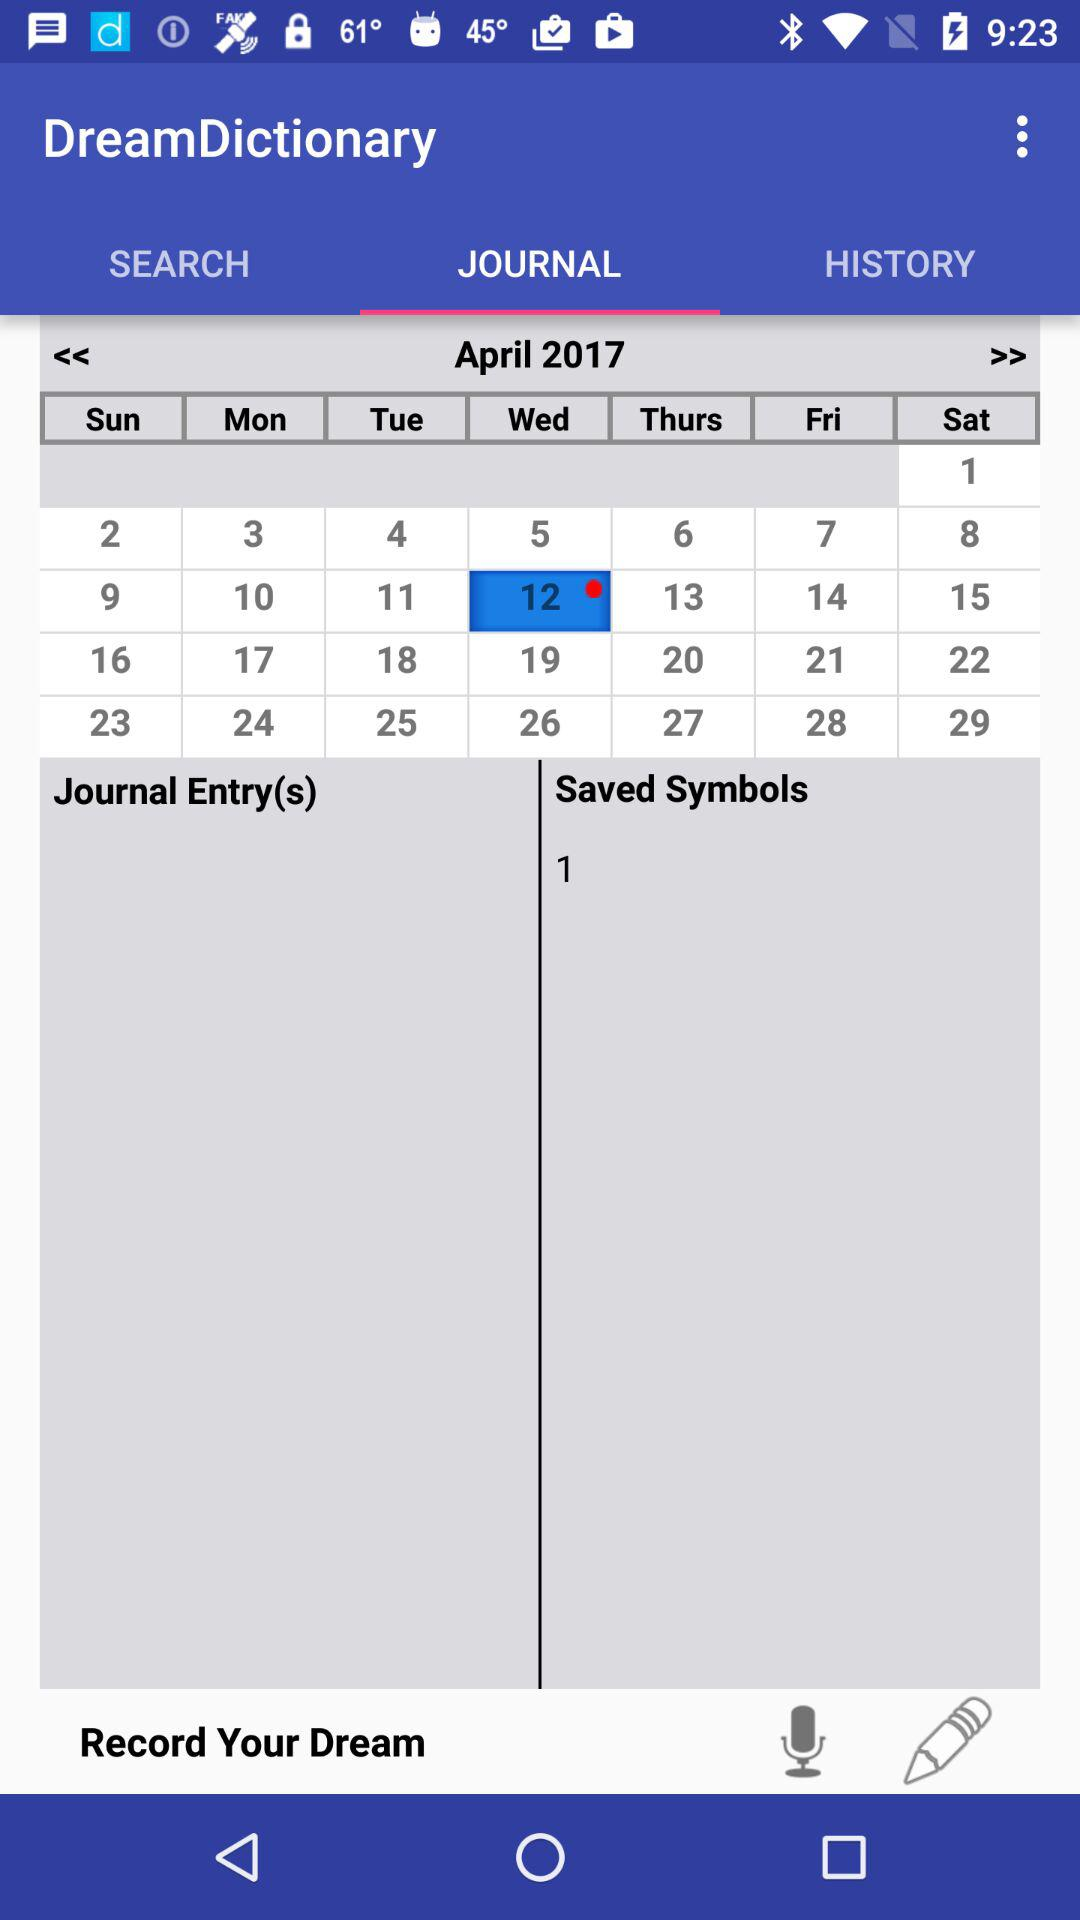What is the selected date? The selected date is April 12, 2017. 